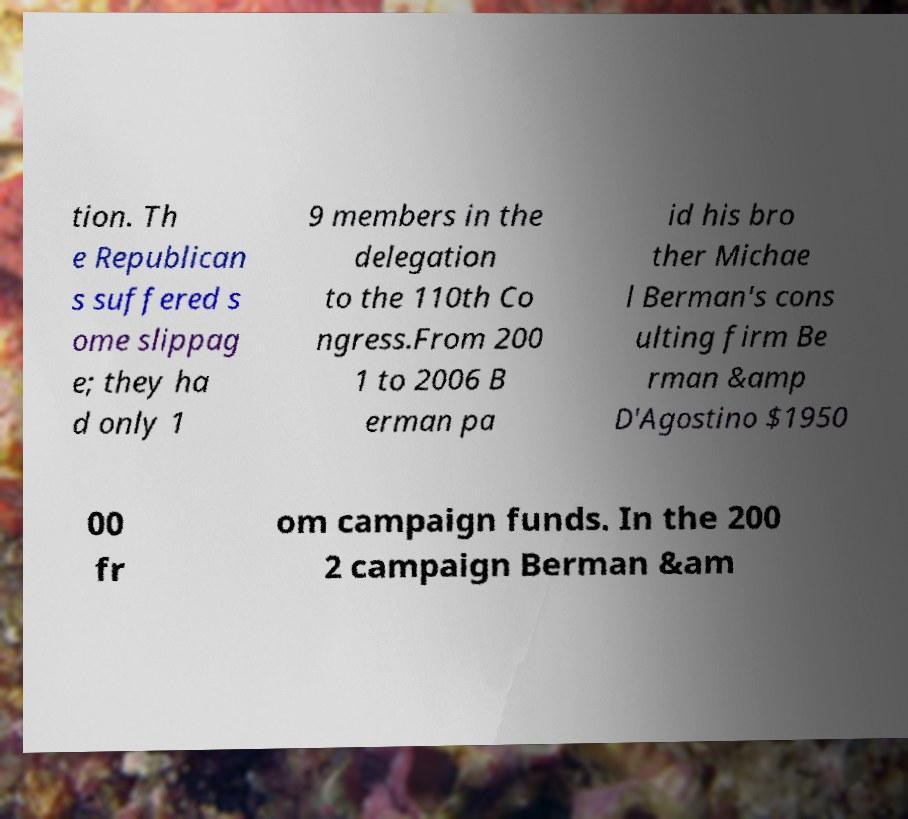Can you read and provide the text displayed in the image?This photo seems to have some interesting text. Can you extract and type it out for me? tion. Th e Republican s suffered s ome slippag e; they ha d only 1 9 members in the delegation to the 110th Co ngress.From 200 1 to 2006 B erman pa id his bro ther Michae l Berman's cons ulting firm Be rman &amp D'Agostino $1950 00 fr om campaign funds. In the 200 2 campaign Berman &am 